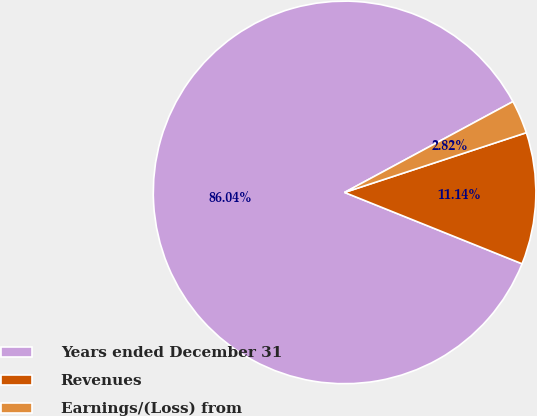<chart> <loc_0><loc_0><loc_500><loc_500><pie_chart><fcel>Years ended December 31<fcel>Revenues<fcel>Earnings/(Loss) from<nl><fcel>86.03%<fcel>11.14%<fcel>2.82%<nl></chart> 